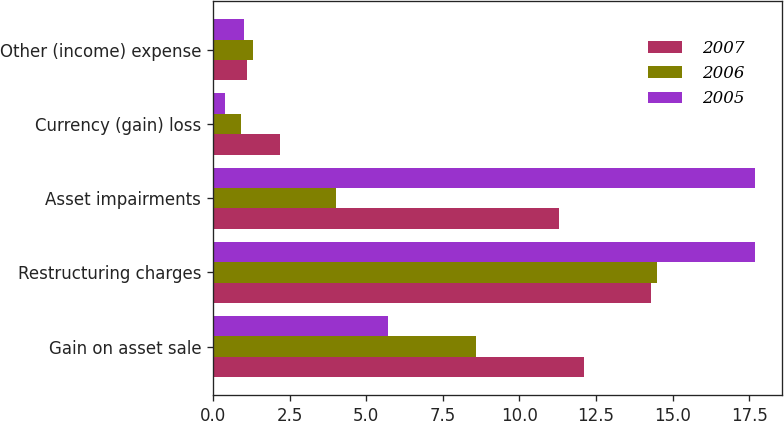Convert chart. <chart><loc_0><loc_0><loc_500><loc_500><stacked_bar_chart><ecel><fcel>Gain on asset sale<fcel>Restructuring charges<fcel>Asset impairments<fcel>Currency (gain) loss<fcel>Other (income) expense<nl><fcel>2007<fcel>12.1<fcel>14.3<fcel>11.3<fcel>2.2<fcel>1.1<nl><fcel>2006<fcel>8.6<fcel>14.5<fcel>4<fcel>0.9<fcel>1.3<nl><fcel>2005<fcel>5.7<fcel>17.7<fcel>17.7<fcel>0.4<fcel>1<nl></chart> 